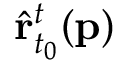<formula> <loc_0><loc_0><loc_500><loc_500>\hat { r } _ { t _ { 0 } } ^ { t } ( p )</formula> 